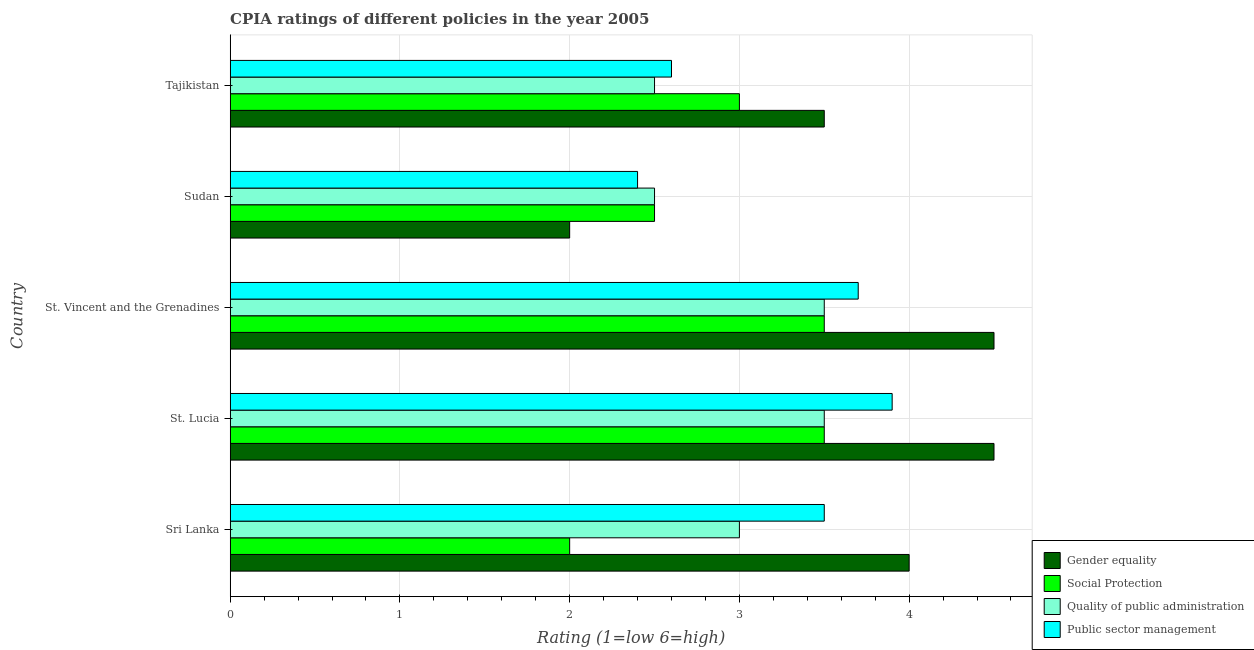How many groups of bars are there?
Keep it short and to the point. 5. Are the number of bars per tick equal to the number of legend labels?
Offer a terse response. Yes. Are the number of bars on each tick of the Y-axis equal?
Ensure brevity in your answer.  Yes. How many bars are there on the 3rd tick from the top?
Give a very brief answer. 4. How many bars are there on the 1st tick from the bottom?
Give a very brief answer. 4. What is the label of the 5th group of bars from the top?
Your response must be concise. Sri Lanka. What is the cpia rating of quality of public administration in St. Vincent and the Grenadines?
Keep it short and to the point. 3.5. Across all countries, what is the maximum cpia rating of gender equality?
Make the answer very short. 4.5. Across all countries, what is the minimum cpia rating of public sector management?
Provide a succinct answer. 2.4. In which country was the cpia rating of gender equality maximum?
Offer a very short reply. St. Lucia. In which country was the cpia rating of gender equality minimum?
Your answer should be very brief. Sudan. What is the difference between the cpia rating of social protection in St. Vincent and the Grenadines and that in Tajikistan?
Offer a terse response. 0.5. What is the difference between the cpia rating of public sector management in Sri Lanka and the cpia rating of quality of public administration in Sudan?
Provide a short and direct response. 1. What is the average cpia rating of gender equality per country?
Provide a short and direct response. 3.7. What is the ratio of the cpia rating of quality of public administration in St. Lucia to that in Tajikistan?
Give a very brief answer. 1.4. Is the difference between the cpia rating of quality of public administration in St. Lucia and Sudan greater than the difference between the cpia rating of social protection in St. Lucia and Sudan?
Your answer should be very brief. No. What is the difference between the highest and the second highest cpia rating of gender equality?
Your response must be concise. 0. What does the 1st bar from the top in St. Lucia represents?
Your answer should be very brief. Public sector management. What does the 4th bar from the bottom in Sudan represents?
Your answer should be very brief. Public sector management. How many bars are there?
Your answer should be compact. 20. What is the difference between two consecutive major ticks on the X-axis?
Give a very brief answer. 1. Are the values on the major ticks of X-axis written in scientific E-notation?
Provide a short and direct response. No. Does the graph contain any zero values?
Provide a succinct answer. No. How many legend labels are there?
Provide a succinct answer. 4. How are the legend labels stacked?
Ensure brevity in your answer.  Vertical. What is the title of the graph?
Offer a very short reply. CPIA ratings of different policies in the year 2005. What is the Rating (1=low 6=high) in Gender equality in Sri Lanka?
Ensure brevity in your answer.  4. What is the Rating (1=low 6=high) of Social Protection in Sri Lanka?
Offer a very short reply. 2. What is the Rating (1=low 6=high) of Public sector management in Sri Lanka?
Give a very brief answer. 3.5. What is the Rating (1=low 6=high) in Gender equality in St. Lucia?
Give a very brief answer. 4.5. What is the Rating (1=low 6=high) in Public sector management in St. Lucia?
Make the answer very short. 3.9. What is the Rating (1=low 6=high) of Social Protection in St. Vincent and the Grenadines?
Offer a terse response. 3.5. What is the Rating (1=low 6=high) of Quality of public administration in St. Vincent and the Grenadines?
Make the answer very short. 3.5. What is the Rating (1=low 6=high) in Public sector management in St. Vincent and the Grenadines?
Give a very brief answer. 3.7. What is the Rating (1=low 6=high) in Social Protection in Sudan?
Give a very brief answer. 2.5. What is the Rating (1=low 6=high) in Public sector management in Sudan?
Provide a short and direct response. 2.4. What is the Rating (1=low 6=high) of Social Protection in Tajikistan?
Keep it short and to the point. 3. What is the Rating (1=low 6=high) of Public sector management in Tajikistan?
Ensure brevity in your answer.  2.6. Across all countries, what is the minimum Rating (1=low 6=high) of Gender equality?
Provide a short and direct response. 2. Across all countries, what is the minimum Rating (1=low 6=high) in Social Protection?
Your answer should be compact. 2. Across all countries, what is the minimum Rating (1=low 6=high) of Quality of public administration?
Your response must be concise. 2.5. Across all countries, what is the minimum Rating (1=low 6=high) of Public sector management?
Offer a terse response. 2.4. What is the total Rating (1=low 6=high) in Gender equality in the graph?
Ensure brevity in your answer.  18.5. What is the total Rating (1=low 6=high) of Quality of public administration in the graph?
Keep it short and to the point. 15. What is the total Rating (1=low 6=high) of Public sector management in the graph?
Provide a succinct answer. 16.1. What is the difference between the Rating (1=low 6=high) in Gender equality in Sri Lanka and that in St. Lucia?
Offer a terse response. -0.5. What is the difference between the Rating (1=low 6=high) in Social Protection in Sri Lanka and that in St. Lucia?
Your response must be concise. -1.5. What is the difference between the Rating (1=low 6=high) in Quality of public administration in Sri Lanka and that in St. Lucia?
Offer a very short reply. -0.5. What is the difference between the Rating (1=low 6=high) of Gender equality in Sri Lanka and that in St. Vincent and the Grenadines?
Ensure brevity in your answer.  -0.5. What is the difference between the Rating (1=low 6=high) of Social Protection in Sri Lanka and that in St. Vincent and the Grenadines?
Your answer should be very brief. -1.5. What is the difference between the Rating (1=low 6=high) in Quality of public administration in Sri Lanka and that in St. Vincent and the Grenadines?
Make the answer very short. -0.5. What is the difference between the Rating (1=low 6=high) of Social Protection in Sri Lanka and that in Tajikistan?
Keep it short and to the point. -1. What is the difference between the Rating (1=low 6=high) in Quality of public administration in Sri Lanka and that in Tajikistan?
Provide a succinct answer. 0.5. What is the difference between the Rating (1=low 6=high) in Public sector management in Sri Lanka and that in Tajikistan?
Give a very brief answer. 0.9. What is the difference between the Rating (1=low 6=high) in Gender equality in St. Lucia and that in St. Vincent and the Grenadines?
Your answer should be compact. 0. What is the difference between the Rating (1=low 6=high) of Gender equality in St. Lucia and that in Sudan?
Your answer should be very brief. 2.5. What is the difference between the Rating (1=low 6=high) in Public sector management in St. Lucia and that in Sudan?
Offer a very short reply. 1.5. What is the difference between the Rating (1=low 6=high) of Social Protection in St. Lucia and that in Tajikistan?
Offer a very short reply. 0.5. What is the difference between the Rating (1=low 6=high) of Quality of public administration in St. Lucia and that in Tajikistan?
Make the answer very short. 1. What is the difference between the Rating (1=low 6=high) of Quality of public administration in St. Vincent and the Grenadines and that in Sudan?
Your answer should be very brief. 1. What is the difference between the Rating (1=low 6=high) in Public sector management in St. Vincent and the Grenadines and that in Sudan?
Keep it short and to the point. 1.3. What is the difference between the Rating (1=low 6=high) of Gender equality in St. Vincent and the Grenadines and that in Tajikistan?
Keep it short and to the point. 1. What is the difference between the Rating (1=low 6=high) of Social Protection in St. Vincent and the Grenadines and that in Tajikistan?
Offer a very short reply. 0.5. What is the difference between the Rating (1=low 6=high) of Public sector management in St. Vincent and the Grenadines and that in Tajikistan?
Give a very brief answer. 1.1. What is the difference between the Rating (1=low 6=high) of Social Protection in Sudan and that in Tajikistan?
Provide a succinct answer. -0.5. What is the difference between the Rating (1=low 6=high) of Quality of public administration in Sudan and that in Tajikistan?
Offer a terse response. 0. What is the difference between the Rating (1=low 6=high) in Gender equality in Sri Lanka and the Rating (1=low 6=high) in Social Protection in St. Lucia?
Your response must be concise. 0.5. What is the difference between the Rating (1=low 6=high) in Gender equality in Sri Lanka and the Rating (1=low 6=high) in Quality of public administration in St. Lucia?
Your answer should be very brief. 0.5. What is the difference between the Rating (1=low 6=high) of Gender equality in Sri Lanka and the Rating (1=low 6=high) of Public sector management in St. Lucia?
Offer a very short reply. 0.1. What is the difference between the Rating (1=low 6=high) of Social Protection in Sri Lanka and the Rating (1=low 6=high) of Quality of public administration in St. Lucia?
Provide a succinct answer. -1.5. What is the difference between the Rating (1=low 6=high) of Quality of public administration in Sri Lanka and the Rating (1=low 6=high) of Public sector management in St. Lucia?
Your answer should be compact. -0.9. What is the difference between the Rating (1=low 6=high) of Gender equality in Sri Lanka and the Rating (1=low 6=high) of Quality of public administration in St. Vincent and the Grenadines?
Provide a short and direct response. 0.5. What is the difference between the Rating (1=low 6=high) of Gender equality in Sri Lanka and the Rating (1=low 6=high) of Public sector management in St. Vincent and the Grenadines?
Your answer should be compact. 0.3. What is the difference between the Rating (1=low 6=high) in Gender equality in Sri Lanka and the Rating (1=low 6=high) in Public sector management in Sudan?
Your answer should be very brief. 1.6. What is the difference between the Rating (1=low 6=high) in Social Protection in Sri Lanka and the Rating (1=low 6=high) in Quality of public administration in Sudan?
Your response must be concise. -0.5. What is the difference between the Rating (1=low 6=high) of Gender equality in Sri Lanka and the Rating (1=low 6=high) of Public sector management in Tajikistan?
Offer a very short reply. 1.4. What is the difference between the Rating (1=low 6=high) in Social Protection in Sri Lanka and the Rating (1=low 6=high) in Quality of public administration in Tajikistan?
Keep it short and to the point. -0.5. What is the difference between the Rating (1=low 6=high) in Social Protection in Sri Lanka and the Rating (1=low 6=high) in Public sector management in Tajikistan?
Ensure brevity in your answer.  -0.6. What is the difference between the Rating (1=low 6=high) of Quality of public administration in Sri Lanka and the Rating (1=low 6=high) of Public sector management in Tajikistan?
Offer a very short reply. 0.4. What is the difference between the Rating (1=low 6=high) of Gender equality in St. Lucia and the Rating (1=low 6=high) of Social Protection in St. Vincent and the Grenadines?
Offer a terse response. 1. What is the difference between the Rating (1=low 6=high) of Gender equality in St. Lucia and the Rating (1=low 6=high) of Quality of public administration in St. Vincent and the Grenadines?
Ensure brevity in your answer.  1. What is the difference between the Rating (1=low 6=high) in Gender equality in St. Lucia and the Rating (1=low 6=high) in Public sector management in St. Vincent and the Grenadines?
Offer a terse response. 0.8. What is the difference between the Rating (1=low 6=high) of Social Protection in St. Lucia and the Rating (1=low 6=high) of Quality of public administration in St. Vincent and the Grenadines?
Offer a terse response. 0. What is the difference between the Rating (1=low 6=high) in Social Protection in St. Lucia and the Rating (1=low 6=high) in Public sector management in St. Vincent and the Grenadines?
Your answer should be very brief. -0.2. What is the difference between the Rating (1=low 6=high) in Gender equality in St. Lucia and the Rating (1=low 6=high) in Quality of public administration in Sudan?
Give a very brief answer. 2. What is the difference between the Rating (1=low 6=high) of Gender equality in St. Lucia and the Rating (1=low 6=high) of Public sector management in Sudan?
Give a very brief answer. 2.1. What is the difference between the Rating (1=low 6=high) of Social Protection in St. Lucia and the Rating (1=low 6=high) of Public sector management in Sudan?
Offer a terse response. 1.1. What is the difference between the Rating (1=low 6=high) of Quality of public administration in St. Lucia and the Rating (1=low 6=high) of Public sector management in Sudan?
Make the answer very short. 1.1. What is the difference between the Rating (1=low 6=high) of Gender equality in St. Lucia and the Rating (1=low 6=high) of Quality of public administration in Tajikistan?
Offer a terse response. 2. What is the difference between the Rating (1=low 6=high) in Gender equality in St. Lucia and the Rating (1=low 6=high) in Public sector management in Tajikistan?
Provide a succinct answer. 1.9. What is the difference between the Rating (1=low 6=high) of Social Protection in St. Lucia and the Rating (1=low 6=high) of Quality of public administration in Tajikistan?
Offer a terse response. 1. What is the difference between the Rating (1=low 6=high) in Social Protection in St. Lucia and the Rating (1=low 6=high) in Public sector management in Tajikistan?
Provide a succinct answer. 0.9. What is the difference between the Rating (1=low 6=high) in Quality of public administration in St. Lucia and the Rating (1=low 6=high) in Public sector management in Tajikistan?
Provide a succinct answer. 0.9. What is the difference between the Rating (1=low 6=high) in Gender equality in St. Vincent and the Grenadines and the Rating (1=low 6=high) in Social Protection in Sudan?
Offer a very short reply. 2. What is the difference between the Rating (1=low 6=high) of Gender equality in St. Vincent and the Grenadines and the Rating (1=low 6=high) of Public sector management in Sudan?
Ensure brevity in your answer.  2.1. What is the difference between the Rating (1=low 6=high) of Social Protection in St. Vincent and the Grenadines and the Rating (1=low 6=high) of Quality of public administration in Sudan?
Offer a terse response. 1. What is the difference between the Rating (1=low 6=high) in Social Protection in St. Vincent and the Grenadines and the Rating (1=low 6=high) in Public sector management in Sudan?
Your response must be concise. 1.1. What is the difference between the Rating (1=low 6=high) of Gender equality in St. Vincent and the Grenadines and the Rating (1=low 6=high) of Social Protection in Tajikistan?
Keep it short and to the point. 1.5. What is the difference between the Rating (1=low 6=high) of Gender equality in St. Vincent and the Grenadines and the Rating (1=low 6=high) of Quality of public administration in Tajikistan?
Offer a very short reply. 2. What is the difference between the Rating (1=low 6=high) in Social Protection in St. Vincent and the Grenadines and the Rating (1=low 6=high) in Quality of public administration in Tajikistan?
Make the answer very short. 1. What is the difference between the Rating (1=low 6=high) in Social Protection in St. Vincent and the Grenadines and the Rating (1=low 6=high) in Public sector management in Tajikistan?
Give a very brief answer. 0.9. What is the difference between the Rating (1=low 6=high) of Gender equality in Sudan and the Rating (1=low 6=high) of Social Protection in Tajikistan?
Keep it short and to the point. -1. What is the difference between the Rating (1=low 6=high) in Gender equality in Sudan and the Rating (1=low 6=high) in Quality of public administration in Tajikistan?
Offer a terse response. -0.5. What is the difference between the Rating (1=low 6=high) of Social Protection in Sudan and the Rating (1=low 6=high) of Quality of public administration in Tajikistan?
Your response must be concise. 0. What is the average Rating (1=low 6=high) of Quality of public administration per country?
Offer a terse response. 3. What is the average Rating (1=low 6=high) in Public sector management per country?
Your response must be concise. 3.22. What is the difference between the Rating (1=low 6=high) of Gender equality and Rating (1=low 6=high) of Social Protection in Sri Lanka?
Provide a short and direct response. 2. What is the difference between the Rating (1=low 6=high) in Gender equality and Rating (1=low 6=high) in Public sector management in Sri Lanka?
Keep it short and to the point. 0.5. What is the difference between the Rating (1=low 6=high) in Quality of public administration and Rating (1=low 6=high) in Public sector management in Sri Lanka?
Provide a succinct answer. -0.5. What is the difference between the Rating (1=low 6=high) of Social Protection and Rating (1=low 6=high) of Quality of public administration in St. Lucia?
Offer a very short reply. 0. What is the difference between the Rating (1=low 6=high) of Social Protection and Rating (1=low 6=high) of Public sector management in St. Lucia?
Your answer should be compact. -0.4. What is the difference between the Rating (1=low 6=high) in Gender equality and Rating (1=low 6=high) in Quality of public administration in St. Vincent and the Grenadines?
Provide a succinct answer. 1. What is the difference between the Rating (1=low 6=high) of Social Protection and Rating (1=low 6=high) of Quality of public administration in St. Vincent and the Grenadines?
Keep it short and to the point. 0. What is the difference between the Rating (1=low 6=high) in Social Protection and Rating (1=low 6=high) in Public sector management in St. Vincent and the Grenadines?
Make the answer very short. -0.2. What is the difference between the Rating (1=low 6=high) in Gender equality and Rating (1=low 6=high) in Public sector management in Sudan?
Your answer should be very brief. -0.4. What is the difference between the Rating (1=low 6=high) in Social Protection and Rating (1=low 6=high) in Quality of public administration in Sudan?
Offer a very short reply. 0. What is the difference between the Rating (1=low 6=high) in Social Protection and Rating (1=low 6=high) in Public sector management in Sudan?
Offer a terse response. 0.1. What is the difference between the Rating (1=low 6=high) in Gender equality and Rating (1=low 6=high) in Quality of public administration in Tajikistan?
Make the answer very short. 1. What is the difference between the Rating (1=low 6=high) of Social Protection and Rating (1=low 6=high) of Public sector management in Tajikistan?
Offer a very short reply. 0.4. What is the ratio of the Rating (1=low 6=high) in Social Protection in Sri Lanka to that in St. Lucia?
Your response must be concise. 0.57. What is the ratio of the Rating (1=low 6=high) in Public sector management in Sri Lanka to that in St. Lucia?
Ensure brevity in your answer.  0.9. What is the ratio of the Rating (1=low 6=high) of Public sector management in Sri Lanka to that in St. Vincent and the Grenadines?
Provide a short and direct response. 0.95. What is the ratio of the Rating (1=low 6=high) in Gender equality in Sri Lanka to that in Sudan?
Make the answer very short. 2. What is the ratio of the Rating (1=low 6=high) in Social Protection in Sri Lanka to that in Sudan?
Your response must be concise. 0.8. What is the ratio of the Rating (1=low 6=high) of Public sector management in Sri Lanka to that in Sudan?
Make the answer very short. 1.46. What is the ratio of the Rating (1=low 6=high) of Gender equality in Sri Lanka to that in Tajikistan?
Your answer should be compact. 1.14. What is the ratio of the Rating (1=low 6=high) in Public sector management in Sri Lanka to that in Tajikistan?
Your answer should be compact. 1.35. What is the ratio of the Rating (1=low 6=high) in Gender equality in St. Lucia to that in St. Vincent and the Grenadines?
Your answer should be compact. 1. What is the ratio of the Rating (1=low 6=high) of Quality of public administration in St. Lucia to that in St. Vincent and the Grenadines?
Make the answer very short. 1. What is the ratio of the Rating (1=low 6=high) of Public sector management in St. Lucia to that in St. Vincent and the Grenadines?
Your answer should be very brief. 1.05. What is the ratio of the Rating (1=low 6=high) in Gender equality in St. Lucia to that in Sudan?
Offer a terse response. 2.25. What is the ratio of the Rating (1=low 6=high) in Social Protection in St. Lucia to that in Sudan?
Your response must be concise. 1.4. What is the ratio of the Rating (1=low 6=high) in Quality of public administration in St. Lucia to that in Sudan?
Ensure brevity in your answer.  1.4. What is the ratio of the Rating (1=low 6=high) of Public sector management in St. Lucia to that in Sudan?
Provide a short and direct response. 1.62. What is the ratio of the Rating (1=low 6=high) in Social Protection in St. Lucia to that in Tajikistan?
Provide a succinct answer. 1.17. What is the ratio of the Rating (1=low 6=high) in Quality of public administration in St. Lucia to that in Tajikistan?
Offer a very short reply. 1.4. What is the ratio of the Rating (1=low 6=high) in Gender equality in St. Vincent and the Grenadines to that in Sudan?
Give a very brief answer. 2.25. What is the ratio of the Rating (1=low 6=high) in Social Protection in St. Vincent and the Grenadines to that in Sudan?
Your answer should be very brief. 1.4. What is the ratio of the Rating (1=low 6=high) of Quality of public administration in St. Vincent and the Grenadines to that in Sudan?
Ensure brevity in your answer.  1.4. What is the ratio of the Rating (1=low 6=high) in Public sector management in St. Vincent and the Grenadines to that in Sudan?
Your response must be concise. 1.54. What is the ratio of the Rating (1=low 6=high) in Social Protection in St. Vincent and the Grenadines to that in Tajikistan?
Make the answer very short. 1.17. What is the ratio of the Rating (1=low 6=high) in Public sector management in St. Vincent and the Grenadines to that in Tajikistan?
Your response must be concise. 1.42. What is the ratio of the Rating (1=low 6=high) in Gender equality in Sudan to that in Tajikistan?
Give a very brief answer. 0.57. What is the ratio of the Rating (1=low 6=high) in Social Protection in Sudan to that in Tajikistan?
Your response must be concise. 0.83. What is the ratio of the Rating (1=low 6=high) in Quality of public administration in Sudan to that in Tajikistan?
Keep it short and to the point. 1. What is the difference between the highest and the second highest Rating (1=low 6=high) in Gender equality?
Give a very brief answer. 0. What is the difference between the highest and the second highest Rating (1=low 6=high) of Quality of public administration?
Keep it short and to the point. 0. What is the difference between the highest and the lowest Rating (1=low 6=high) in Gender equality?
Your response must be concise. 2.5. What is the difference between the highest and the lowest Rating (1=low 6=high) in Social Protection?
Your response must be concise. 1.5. What is the difference between the highest and the lowest Rating (1=low 6=high) in Quality of public administration?
Your response must be concise. 1. What is the difference between the highest and the lowest Rating (1=low 6=high) in Public sector management?
Your answer should be compact. 1.5. 